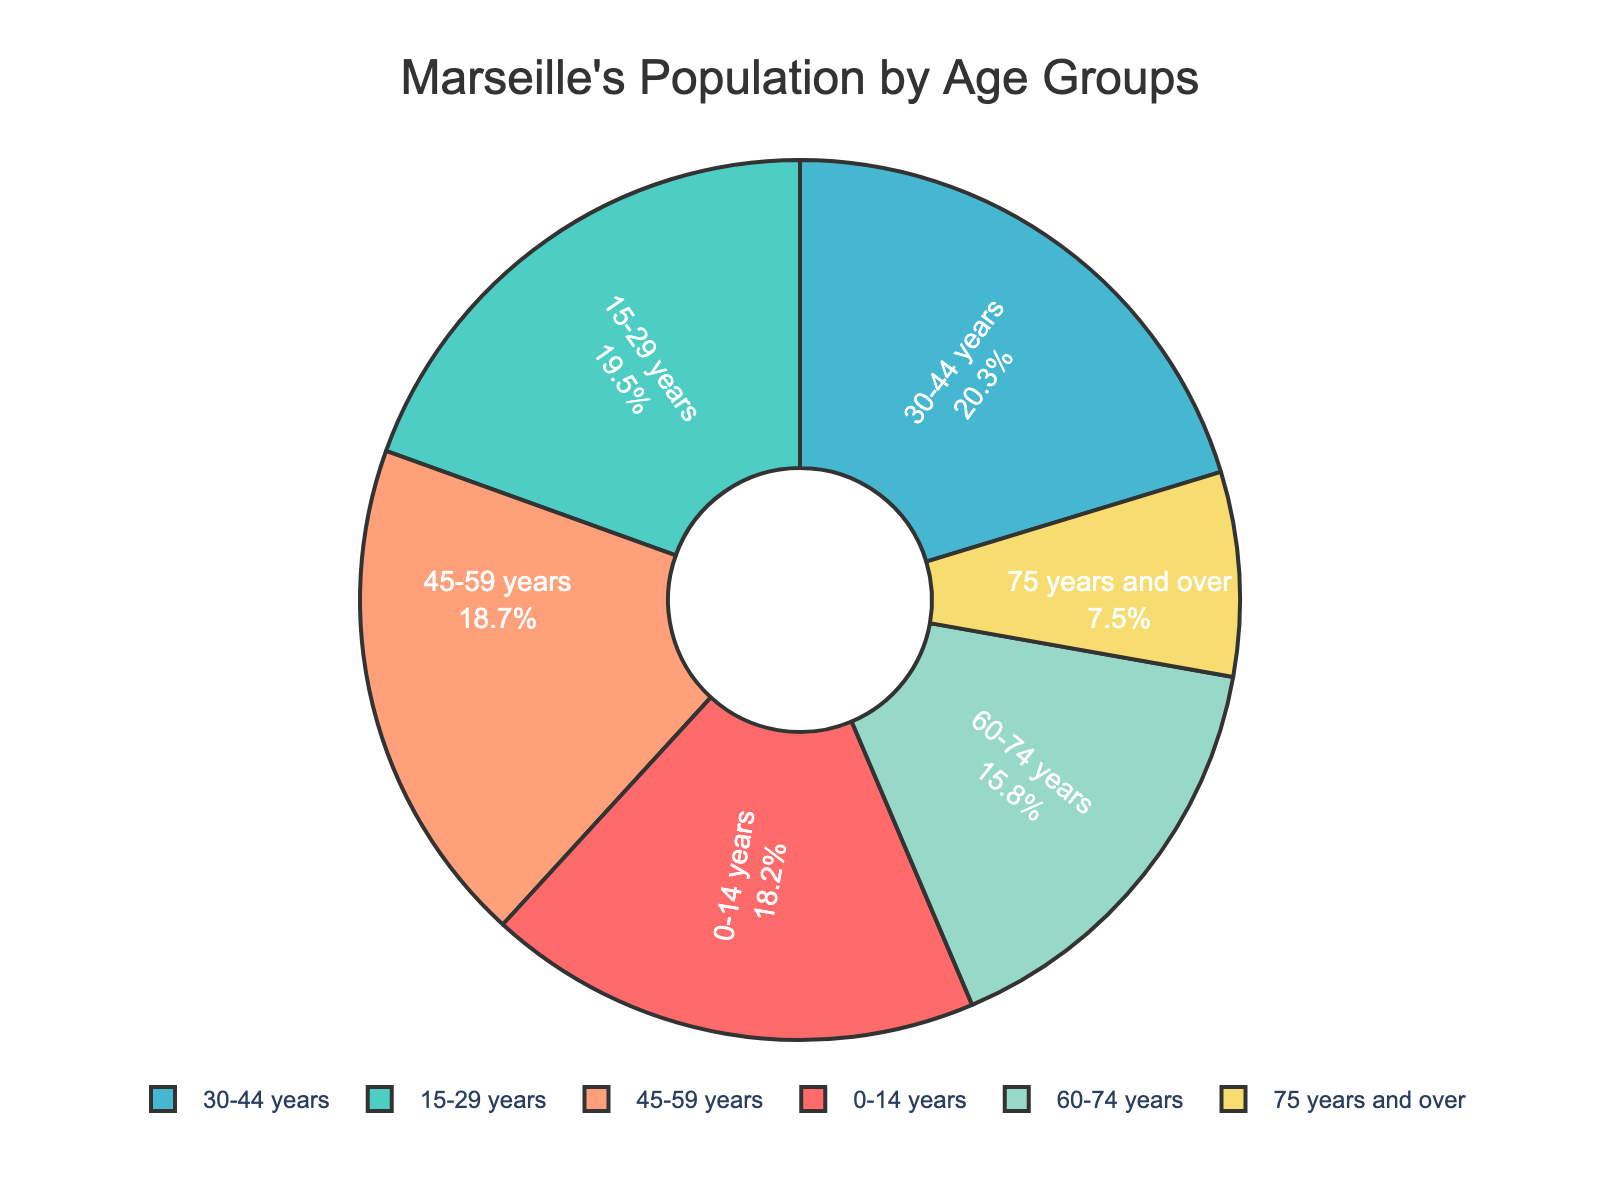What's the largest age group in Marseille's population? To find the largest age group, examine the pie chart for the segment with the largest percentage. This age group has the highest percentage.
Answer: 30-44 years Which age group has the smallest representation in Marseille's population? Look for the segment with the smallest percentage on the pie chart. The age group with the smallest segment is the least represented.
Answer: 75 years and over How do the combined percentages of the oldest two age groups compare with the age group of 30-44 years? Add the percentages of the age groups 60-74 years and 75 years and over (15.8 + 7.5) and compare the sum to the percentage of the 30-44 years group. The difference will help determine the comparison.
Answer: Lower (15.8 + 7.5 = 23.3, which is less than 20.3) What is the total percentage of the population that is 0-29 years old? Add the percentages of the age groups 0-14 years and 15-29 years (18.2 + 19.5). The result will give the total percentage of population aged 0-29 years.
Answer: 37.7% How do the combined percentages of the age groups 0-14 years and 45-59 years compare to the age group of 15-29 years? Add the percentages for the age groups 0-14 years and 45-59 years (18.2 + 18.7) and compare with the percentage for 15-29 years. The difference will show the comparison.
Answer: Higher (18.2 + 18.7 = 36.9, which is higher than 19.5) Which color represents the age group 60-74 years? Identify the segment labeled 60-74 years. The segment's color on the pie chart indicates the color for this age group.
Answer: Yellow What is the percentage difference between the age groups 0-14 years and 45-59 years? Subtract the percentage of the age group 0-14 years from the percentage of the age group 45-59 years (18.7 - 18.2). The result is the difference.
Answer: 0.5% How many percentage points higher is the 30-44 years age group compared to the 60-74 years age group? Subtract the percentage of the 60-74 years group from the 30-44 years group (20.3 - 15.8). The result will be the difference in percentage points.
Answer: 4.5% Is the percentage of the population aged 15-29 years closer to the age group 30-44 years or 0-14 years? Compare the absolute differences between the percentages of 15-29 years and both 30-44 years and 0-14 years. Determine which difference is smaller.
Answer: Closer to 30-44 years (0.8 vs 1.3) 